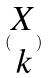<formula> <loc_0><loc_0><loc_500><loc_500>( \begin{matrix} X \\ k \end{matrix} )</formula> 